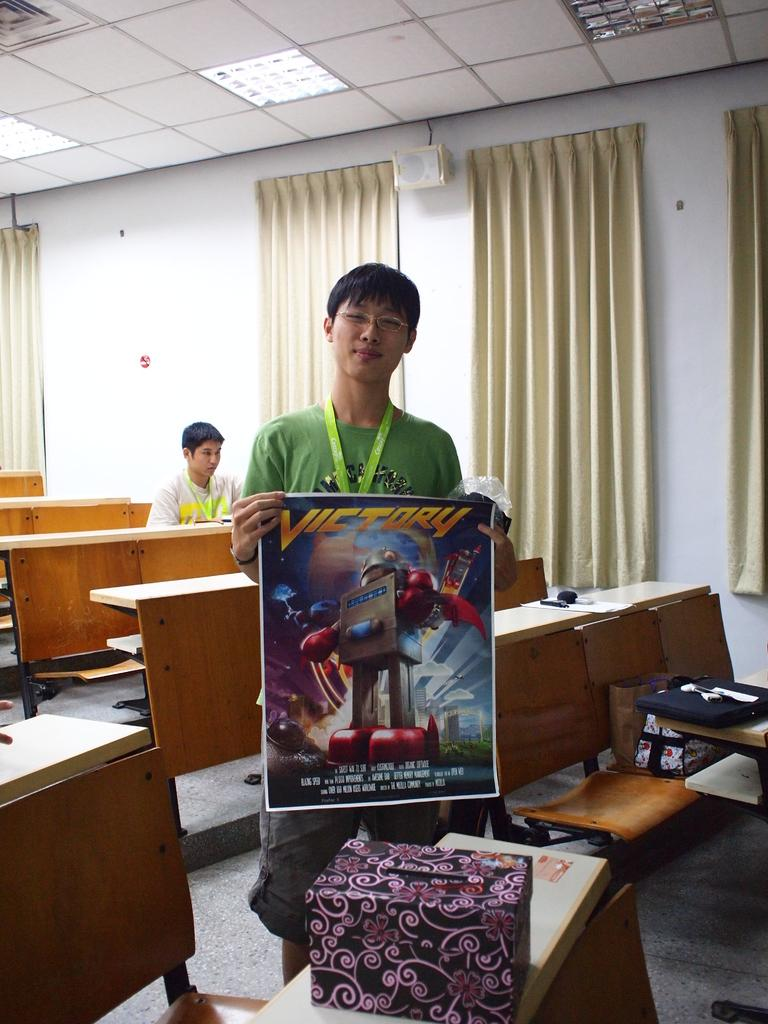What type of furniture is visible in the image? There are tables in the image. What object can be seen on one of the tables? There is a box on one of the tables. What is the man in the image doing? The man is holding a poster in the image. What can be seen in the background of the image? Cream-colored curtains are present in the background of the image. Can you tell me what advice the snake is giving to the man in the image? There is no snake present in the image, so it is not possible to determine any advice given. What type of picture is the man holding in the image? The provided facts do not specify the content or type of the poster the man is holding, so it cannot be determined from the image. 